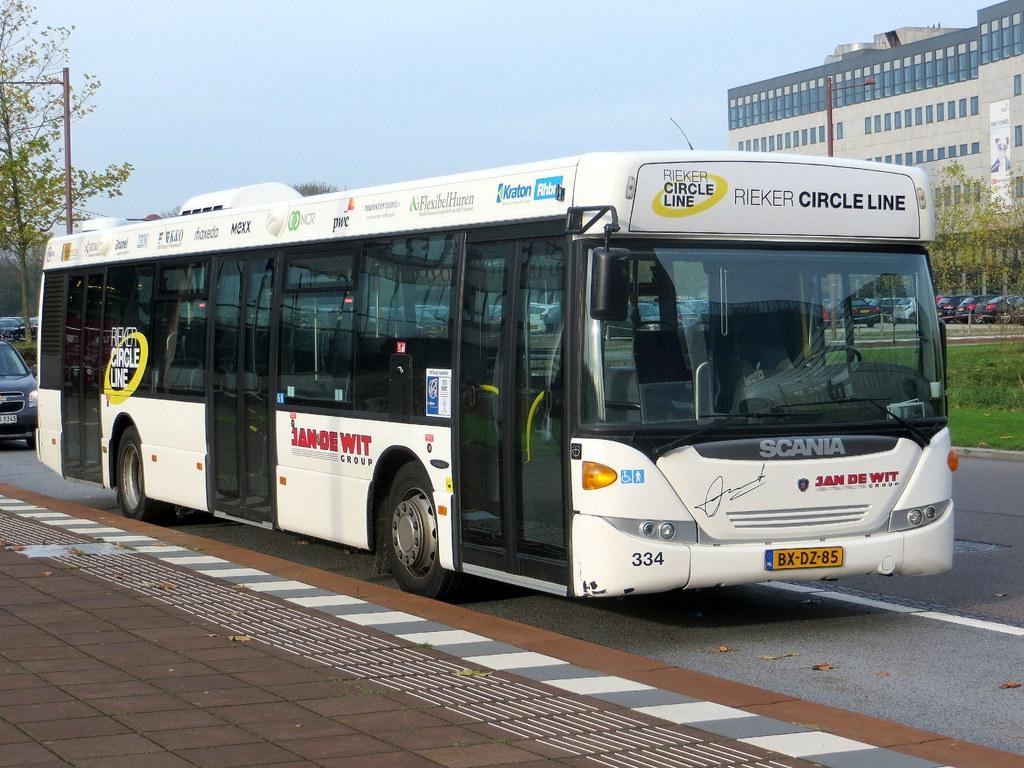<image>
Share a concise interpretation of the image provided. A white bus with the words Rieker circle line on it 